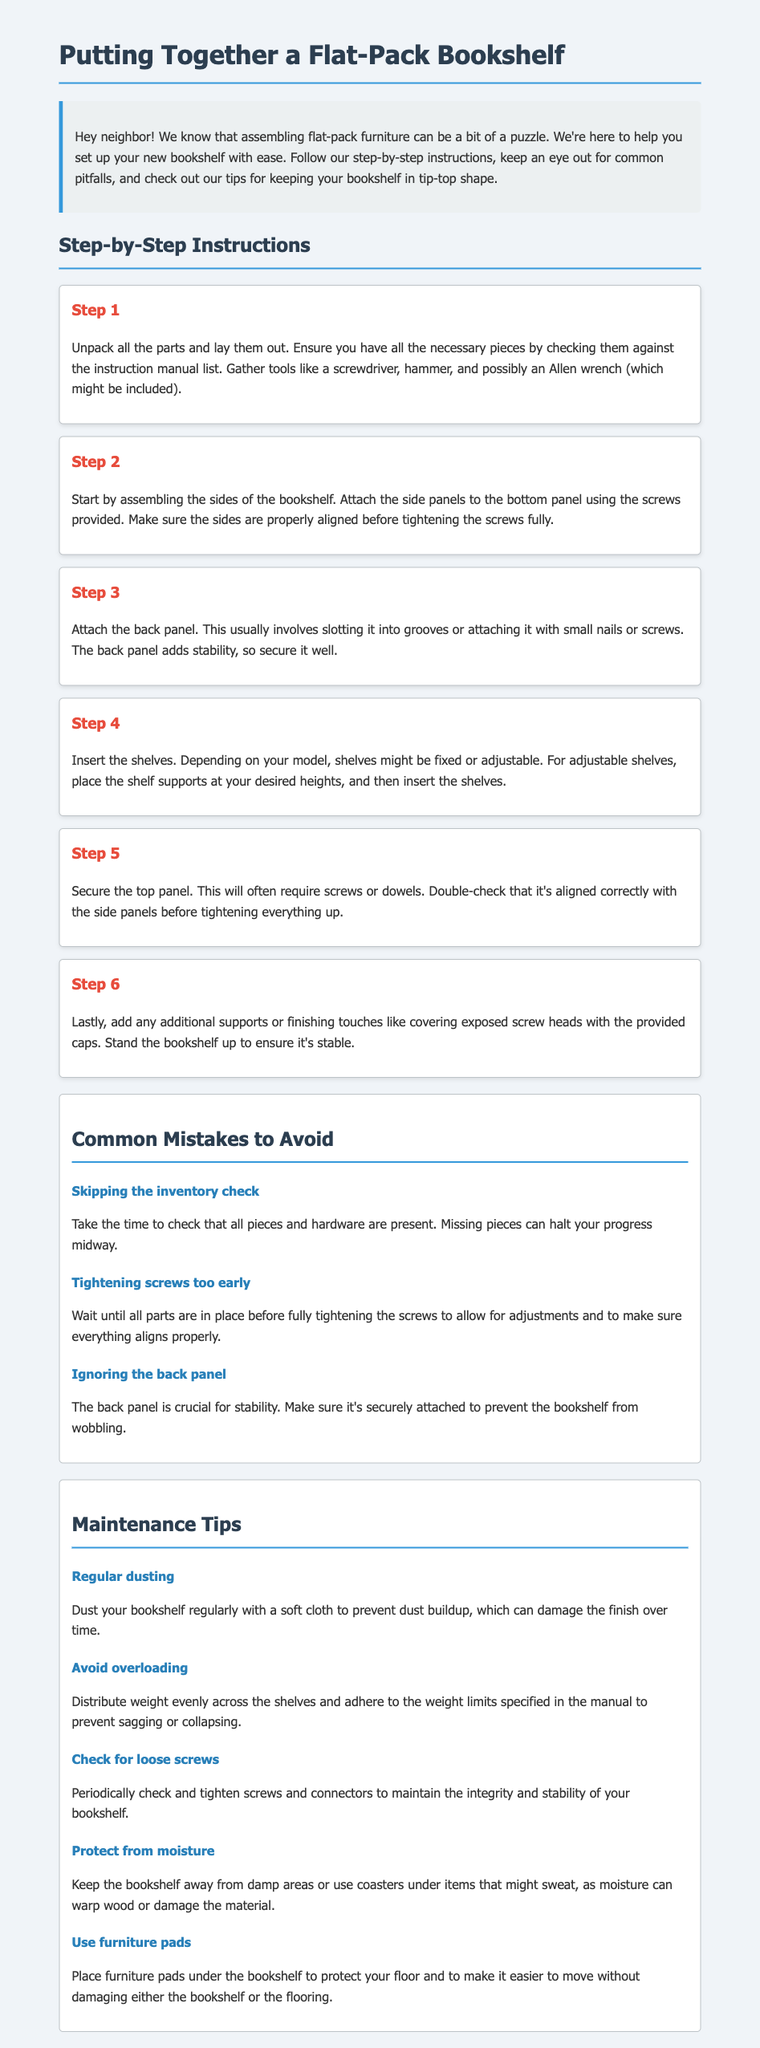What is the first step in assembling the bookshelf? The first step is to unpack all the parts and lay them out, ensuring you have all necessary pieces.
Answer: Unpack all parts What tool might be included with the bookshelf? The instruction document mentions that an Allen wrench might be included as a tool.
Answer: Allen wrench How many steps are there in the assembly instructions? The document outlines a total of six steps for assembling the bookshelf.
Answer: Six What is a common mistake to avoid while assembling? One common mistake to avoid is skipping the inventory check to ensure all pieces are present.
Answer: Skipping the inventory check What should you do to maintain your bookshelf regarding dust? According to the maintenance tips, you should regularly dust your bookshelf to prevent dust buildup.
Answer: Regular dusting What is recommended for preventing moisture damage? The document advises keeping the bookshelf away from damp areas or using coasters under sweating items.
Answer: Keep away from damp areas What step involves adding final touches? The last step involves adding any additional supports or finishing touches like covering exposed screw heads.
Answer: Step 6 How can you protect the floor when moving the bookshelf? The maintenance section suggests placing furniture pads under the bookshelf to protect the floor during movement.
Answer: Use furniture pads 